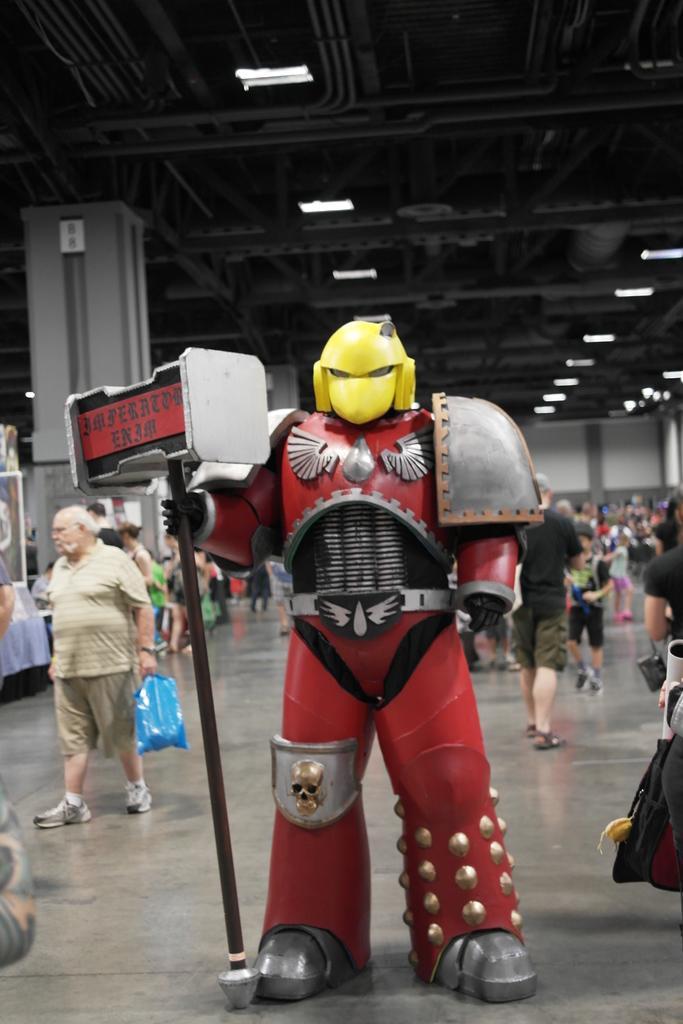Could you give a brief overview of what you see in this image? In this image I can see in the middle there is the doll. At the back side few people are working, at the top there are lights. 